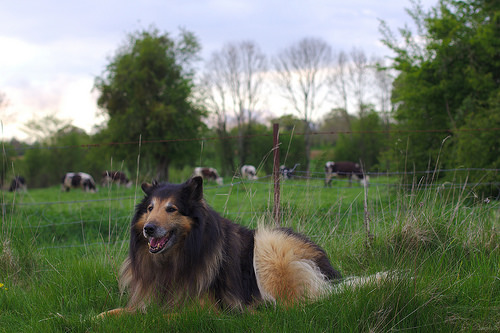<image>
Is there a dog next to the fence? Yes. The dog is positioned adjacent to the fence, located nearby in the same general area. Is there a dog in the fence? No. The dog is not contained within the fence. These objects have a different spatial relationship. Is the cow behind the dog? Yes. From this viewpoint, the cow is positioned behind the dog, with the dog partially or fully occluding the cow. 